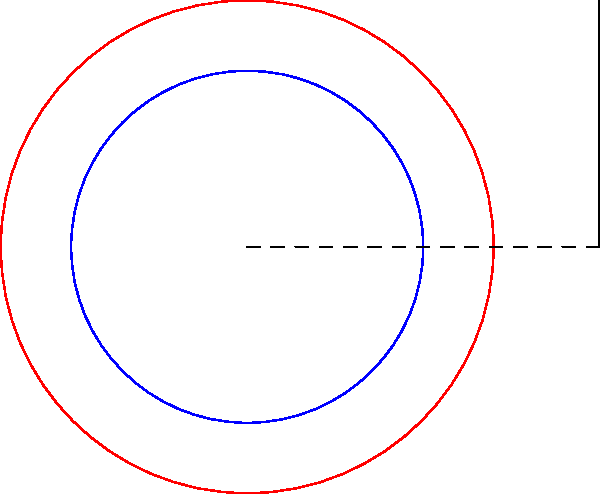As a jazz enthusiast, you're interested in the mechanics of vinyl players. A tonearm sweeps through an angle as it moves from the outer edge to the inner edge of a record. Given that the tonearm pivot is 10 cm from the center of the turntable, calculate the difference in sweep angles for a 12-inch vinyl (radius 15 cm) and a 7-inch vinyl (radius 8.75 cm). Express your answer in degrees, rounded to the nearest whole number. Let's approach this step-by-step:

1) We can use the arctangent function to calculate the sweep angle for each record size. The formula is:

   $\theta = \arctan(\frac{r}{a})$

   where $r$ is the radius of the record and $a$ is the distance from the pivot to the center of the turntable.

2) For the 12-inch vinyl:
   $r_1 = 15$ cm, $a = 10$ cm
   $\theta_1 = \arctan(\frac{15}{10}) = \arctan(1.5)$

3) For the 7-inch vinyl:
   $r_2 = 8.75$ cm, $a = 10$ cm
   $\theta_2 = \arctan(\frac{8.75}{10}) = \arctan(0.875)$

4) Calculate $\theta_1$:
   $\theta_1 = \arctan(1.5) \approx 0.982793723$ radians

5) Calculate $\theta_2$:
   $\theta_2 = \arctan(0.875) \approx 0.718295913$ radians

6) Find the difference:
   $\Delta\theta = \theta_1 - \theta_2 \approx 0.264497810$ radians

7) Convert to degrees:
   $\Delta\theta_{degrees} = 0.264497810 \times \frac{180}{\pi} \approx 15.15°$

8) Rounding to the nearest whole number:
   $\Delta\theta_{rounded} = 15°$
Answer: 15° 